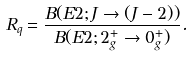Convert formula to latex. <formula><loc_0><loc_0><loc_500><loc_500>R _ { q } = \frac { B ( E 2 ; J \to ( J - 2 ) ) } { B ( E 2 ; 2 ^ { + } _ { g } \to 0 ^ { + } _ { g } ) } .</formula> 